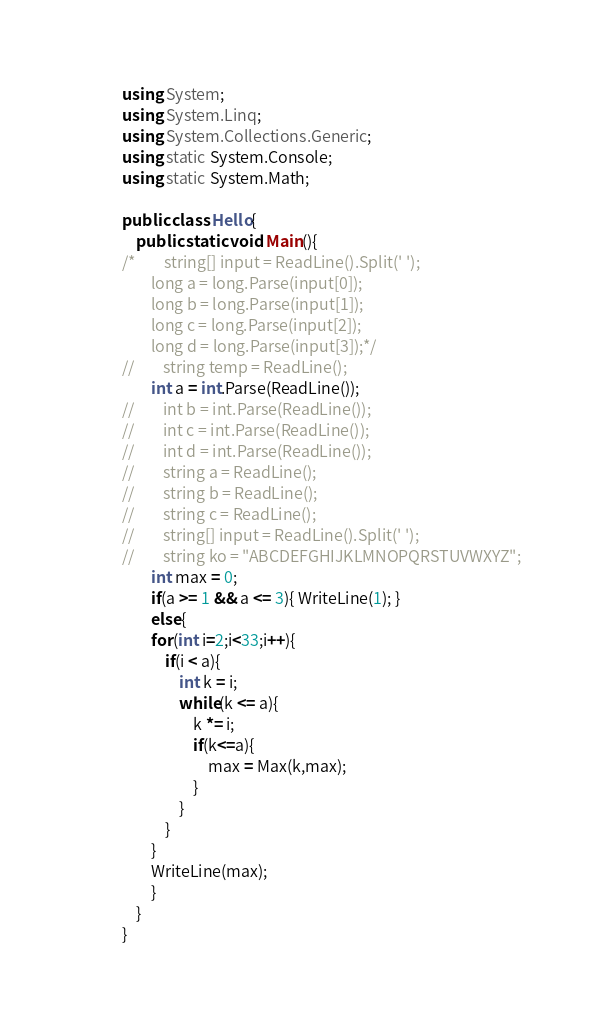Convert code to text. <code><loc_0><loc_0><loc_500><loc_500><_C#_>using System;
using System.Linq;
using System.Collections.Generic;
using static System.Console;
using static System.Math;
 
public class Hello{
    public static void Main(){
/*        string[] input = ReadLine().Split(' ');
        long a = long.Parse(input[0]);
        long b = long.Parse(input[1]);
        long c = long.Parse(input[2]);
        long d = long.Parse(input[3]);*/
//        string temp = ReadLine();
        int a = int.Parse(ReadLine());
//        int b = int.Parse(ReadLine());
//        int c = int.Parse(ReadLine());
//        int d = int.Parse(ReadLine());
//        string a = ReadLine();
//        string b = ReadLine();
//        string c = ReadLine();
//        string[] input = ReadLine().Split(' ');
//        string ko = "ABCDEFGHIJKLMNOPQRSTUVWXYZ";
        int max = 0;
        if(a >= 1 && a <= 3){ WriteLine(1); }
        else{
        for(int i=2;i<33;i++){
            if(i < a){
                int k = i;
                while(k <= a){
                    k *= i;
                    if(k<=a){
                        max = Max(k,max);
                    }
                }
            }
        }
        WriteLine(max);
        }
    }
}</code> 